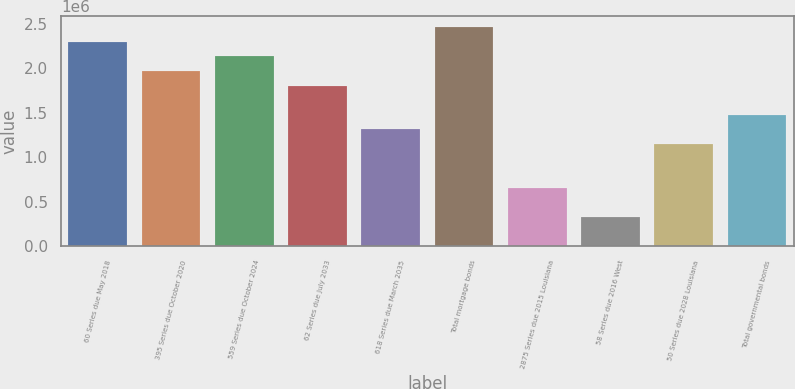Convert chart to OTSL. <chart><loc_0><loc_0><loc_500><loc_500><bar_chart><fcel>60 Series due May 2018<fcel>395 Series due October 2020<fcel>559 Series due October 2024<fcel>62 Series due July 2033<fcel>618 Series due March 2035<fcel>Total mortgage bonds<fcel>2875 Series due 2015 Louisiana<fcel>58 Series due 2016 West<fcel>50 Series due 2028 Louisiana<fcel>Total governmental bonds<nl><fcel>2.29852e+06<fcel>1.97046e+06<fcel>2.13449e+06<fcel>1.80642e+06<fcel>1.31432e+06<fcel>2.46256e+06<fcel>658184<fcel>330116<fcel>1.15029e+06<fcel>1.47835e+06<nl></chart> 